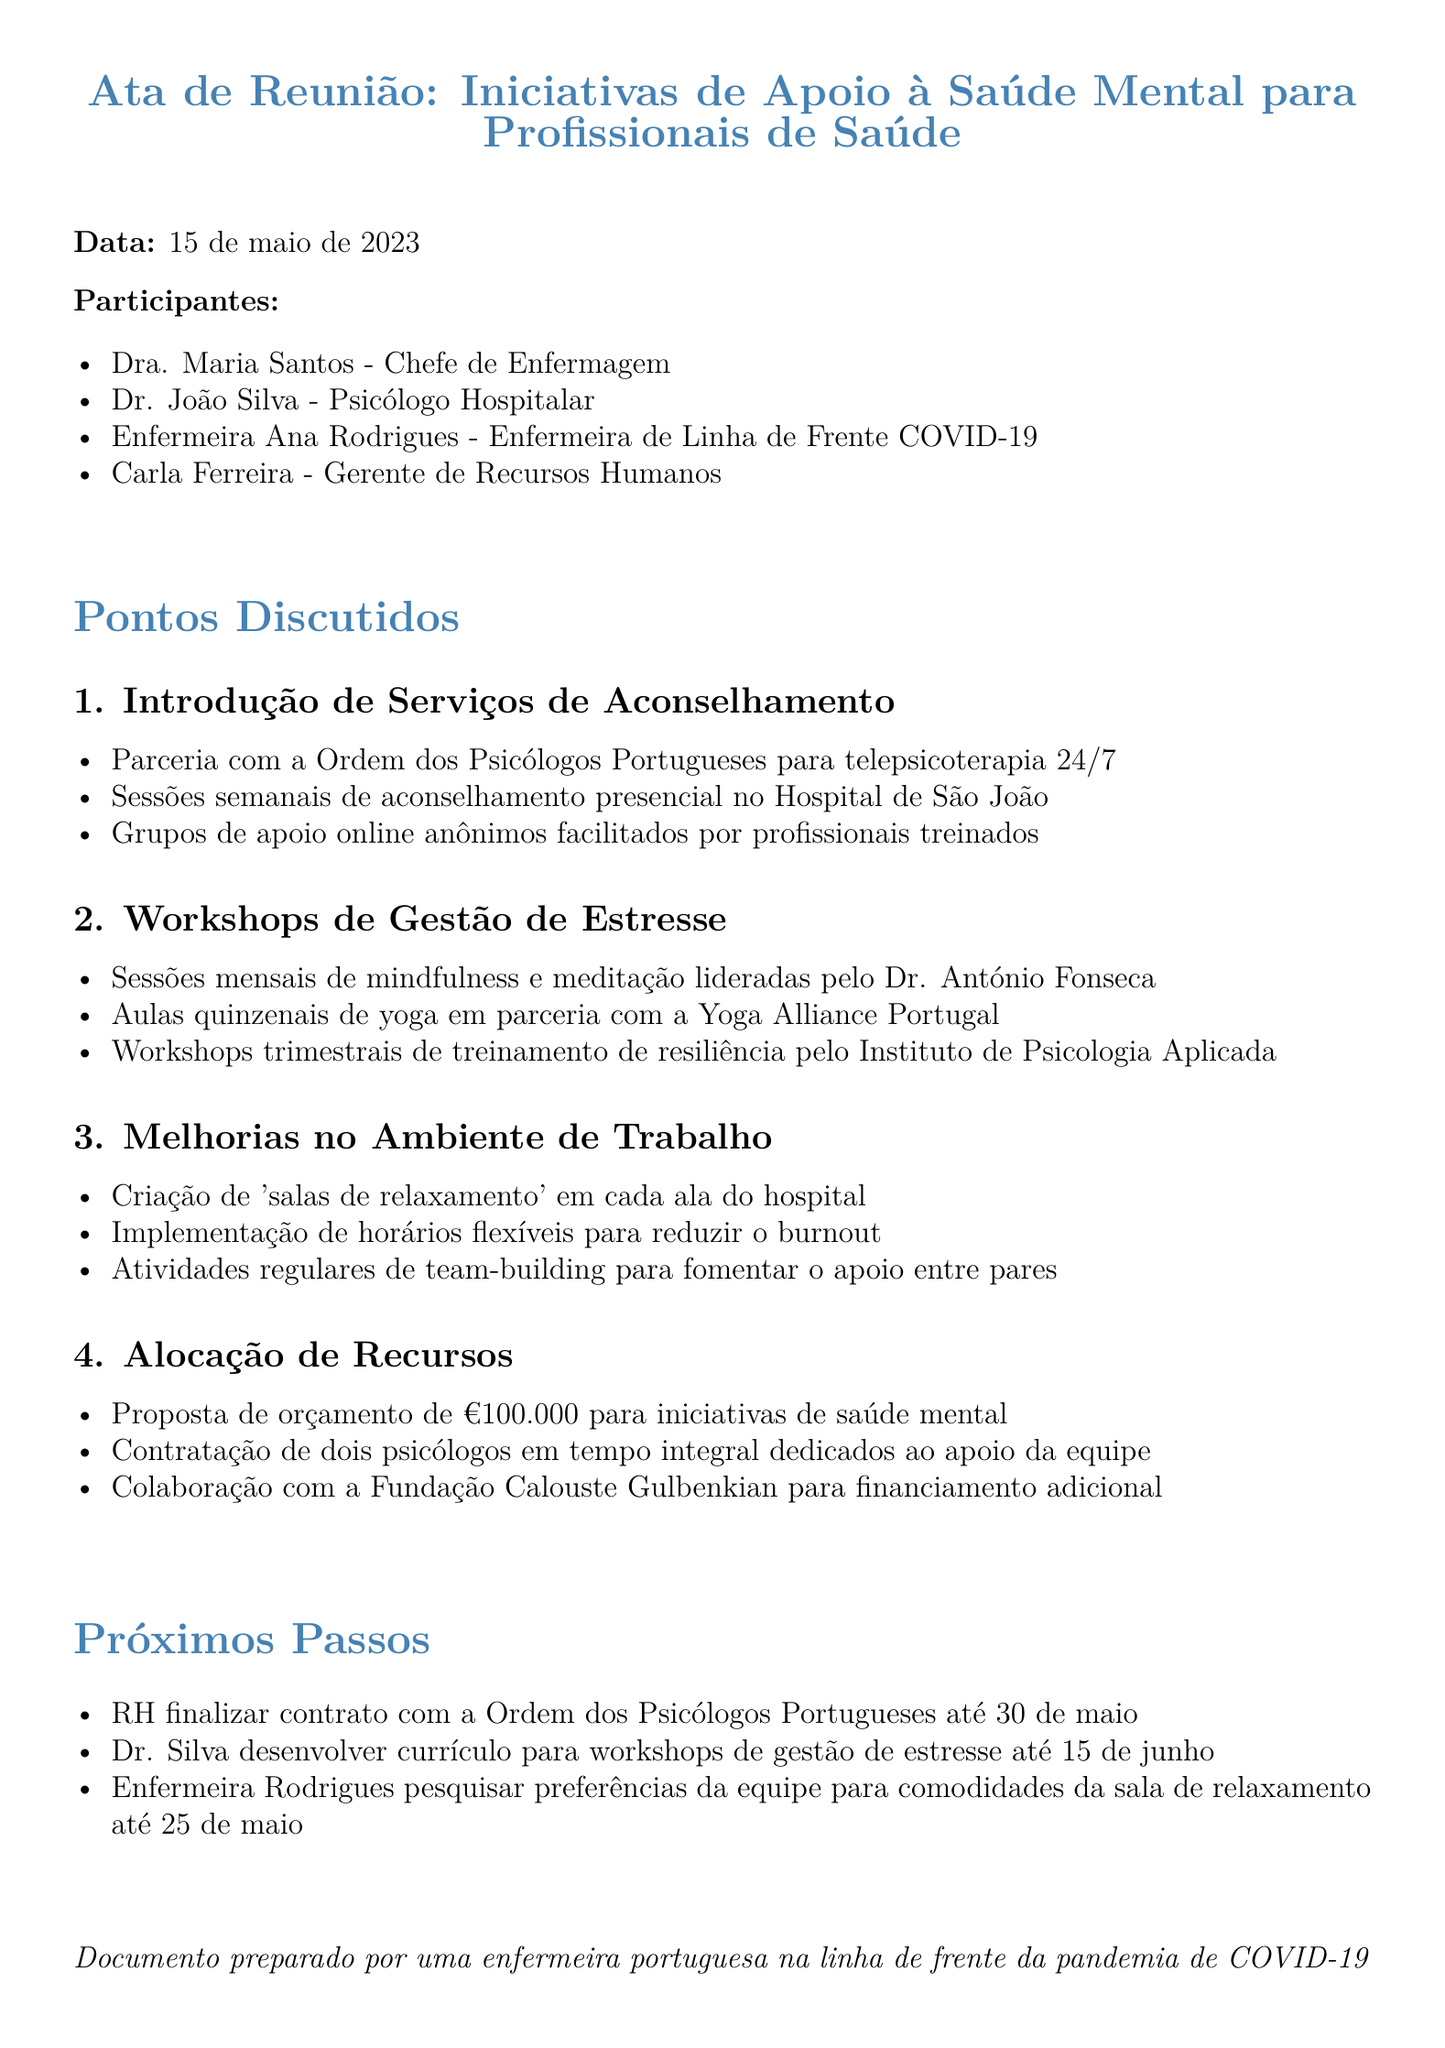What is the title of the meeting? The title is mentioned at the beginning of the document under "meeting_title", which is about mental health support initiatives for healthcare workers.
Answer: Mental Health Support Initiatives for Healthcare Workers Who is the Chief of Nursing? The document lists the attendees, providing the name and title of the Chief of Nursing.
Answer: Dr. Maria Santos How many attendees were present at the meeting? The document enumerates the participants at the meeting under "attendees", specifying the total number of individuals listed.
Answer: 4 What is the budget proposal for mental health initiatives? The document outlines financial details under "Resource Allocation", specifying the proposed budget for mental health initiatives.
Answer: €100,000 What is one type of counseling service introduced? The document describes various services under "Introduction of Counseling Services", detailing specific initiatives provided.
Answer: Teletherapy 24/7 Who will finalize the contract with the Ordem dos Psicólogos Portugueses? The action items section of the document specifies who is responsible for finalizing the contract.
Answer: HR When is the deadline for the survey regarding relaxation room amenities? The document notes the timeline for action items, including the survey deadline.
Answer: May 25 What professional will lead the mindfulness and meditation sessions? The document mentions the individual responsible for these sessions in the outline of the workshops.
Answer: Dr. António Fonseca How often will the yoga classes be held? The frequency of the yoga classes is specified in the details of the stress management workshops section.
Answer: Bi-weekly 